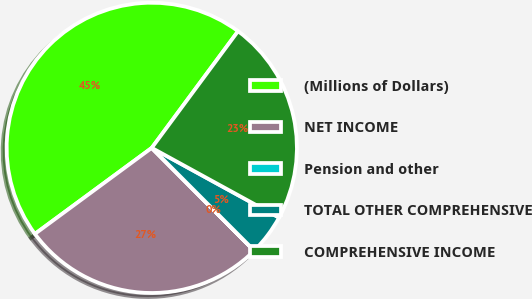Convert chart to OTSL. <chart><loc_0><loc_0><loc_500><loc_500><pie_chart><fcel>(Millions of Dollars)<fcel>NET INCOME<fcel>Pension and other<fcel>TOTAL OTHER COMPREHENSIVE<fcel>COMPREHENSIVE INCOME<nl><fcel>45.23%<fcel>27.36%<fcel>0.02%<fcel>4.54%<fcel>22.84%<nl></chart> 